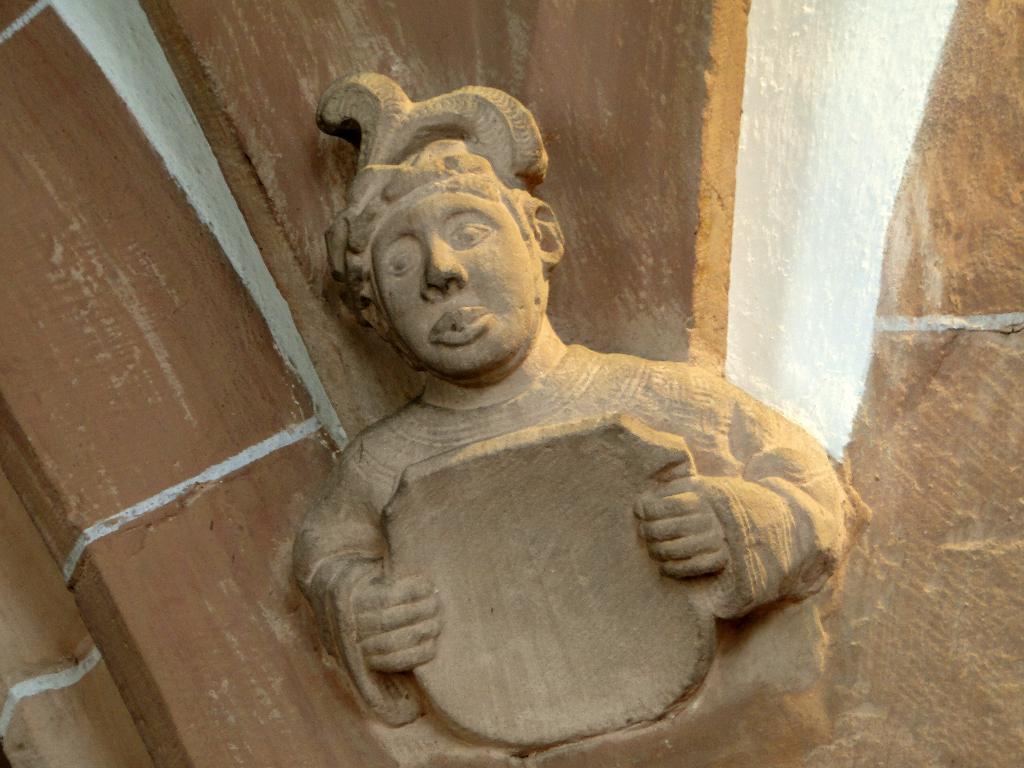How would you summarize this image in a sentence or two? In this picture I can see a sculpture of a person holding an object. 